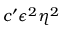Convert formula to latex. <formula><loc_0><loc_0><loc_500><loc_500>c ^ { \prime } \epsilon ^ { 2 } \eta ^ { 2 }</formula> 